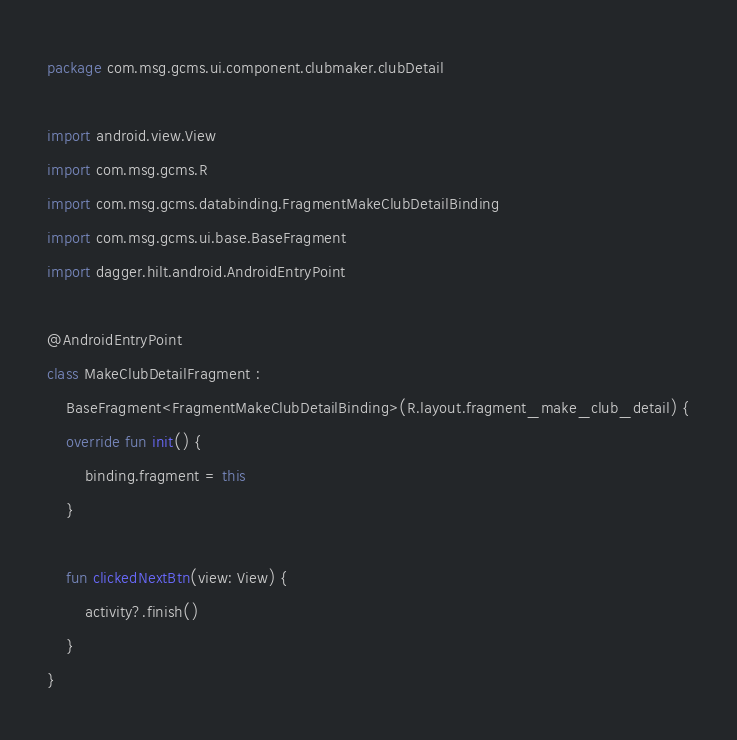Convert code to text. <code><loc_0><loc_0><loc_500><loc_500><_Kotlin_>package com.msg.gcms.ui.component.clubmaker.clubDetail

import android.view.View
import com.msg.gcms.R
import com.msg.gcms.databinding.FragmentMakeClubDetailBinding
import com.msg.gcms.ui.base.BaseFragment
import dagger.hilt.android.AndroidEntryPoint

@AndroidEntryPoint
class MakeClubDetailFragment :
    BaseFragment<FragmentMakeClubDetailBinding>(R.layout.fragment_make_club_detail) {
    override fun init() {
        binding.fragment = this
    }

    fun clickedNextBtn(view: View) {
        activity?.finish()
    }
}
</code> 